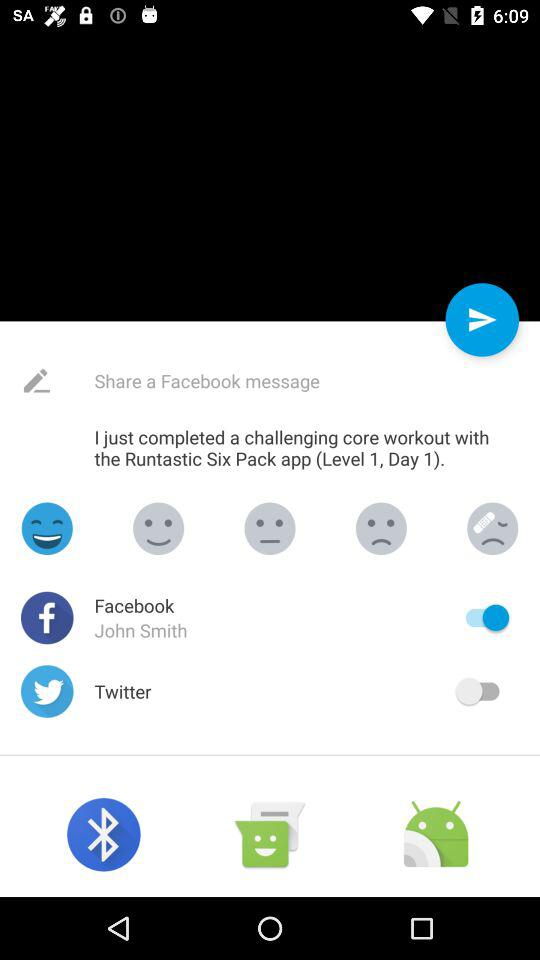How many social media platforms are there?
Answer the question using a single word or phrase. 2 